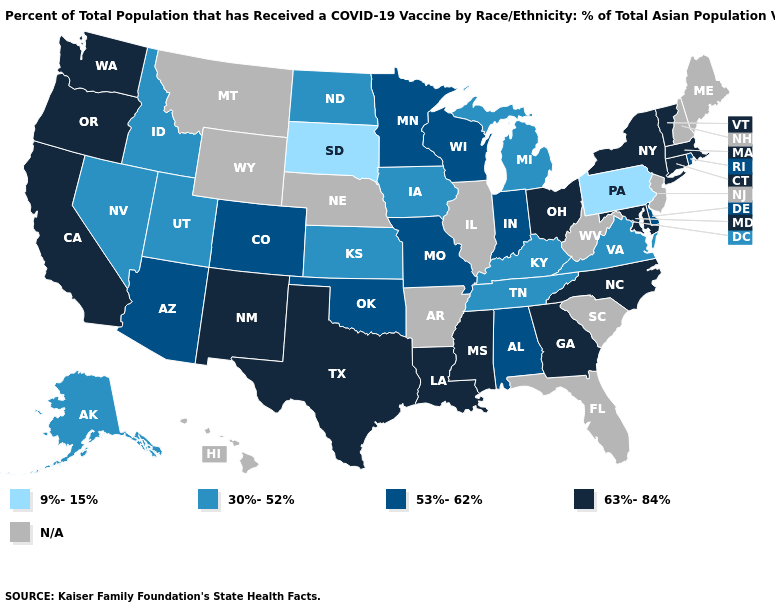Name the states that have a value in the range 30%-52%?
Keep it brief. Alaska, Idaho, Iowa, Kansas, Kentucky, Michigan, Nevada, North Dakota, Tennessee, Utah, Virginia. What is the lowest value in the South?
Write a very short answer. 30%-52%. Among the states that border Iowa , does Minnesota have the lowest value?
Concise answer only. No. What is the value of New York?
Short answer required. 63%-84%. Name the states that have a value in the range 9%-15%?
Keep it brief. Pennsylvania, South Dakota. Among the states that border South Dakota , does Iowa have the lowest value?
Concise answer only. Yes. What is the highest value in the USA?
Be succinct. 63%-84%. What is the value of North Carolina?
Concise answer only. 63%-84%. Name the states that have a value in the range N/A?
Quick response, please. Arkansas, Florida, Hawaii, Illinois, Maine, Montana, Nebraska, New Hampshire, New Jersey, South Carolina, West Virginia, Wyoming. Name the states that have a value in the range 53%-62%?
Quick response, please. Alabama, Arizona, Colorado, Delaware, Indiana, Minnesota, Missouri, Oklahoma, Rhode Island, Wisconsin. Which states hav the highest value in the MidWest?
Short answer required. Ohio. What is the value of Pennsylvania?
Be succinct. 9%-15%. Name the states that have a value in the range 30%-52%?
Quick response, please. Alaska, Idaho, Iowa, Kansas, Kentucky, Michigan, Nevada, North Dakota, Tennessee, Utah, Virginia. Among the states that border Maryland , which have the highest value?
Give a very brief answer. Delaware. Among the states that border North Dakota , does Minnesota have the highest value?
Quick response, please. Yes. 